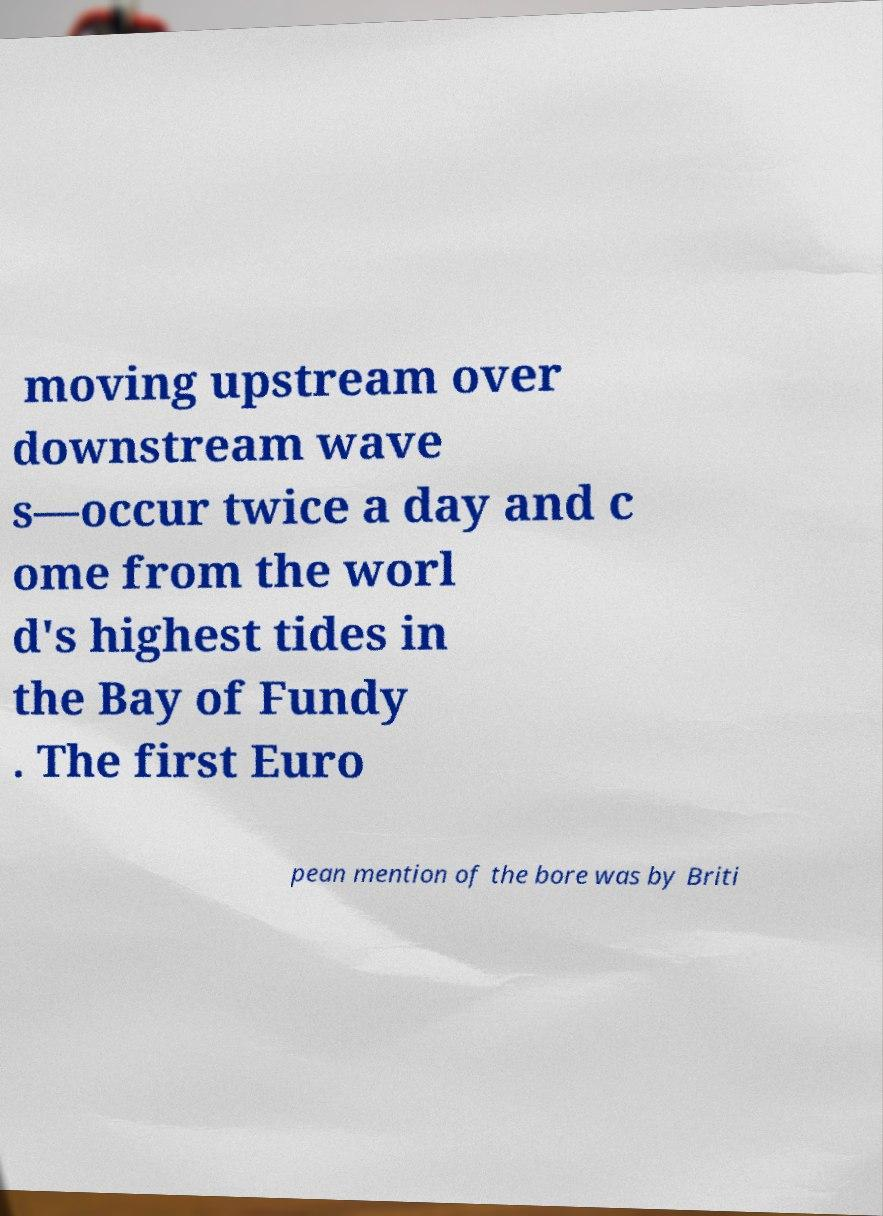Can you read and provide the text displayed in the image?This photo seems to have some interesting text. Can you extract and type it out for me? moving upstream over downstream wave s—occur twice a day and c ome from the worl d's highest tides in the Bay of Fundy . The first Euro pean mention of the bore was by Briti 